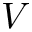Convert formula to latex. <formula><loc_0><loc_0><loc_500><loc_500>V</formula> 